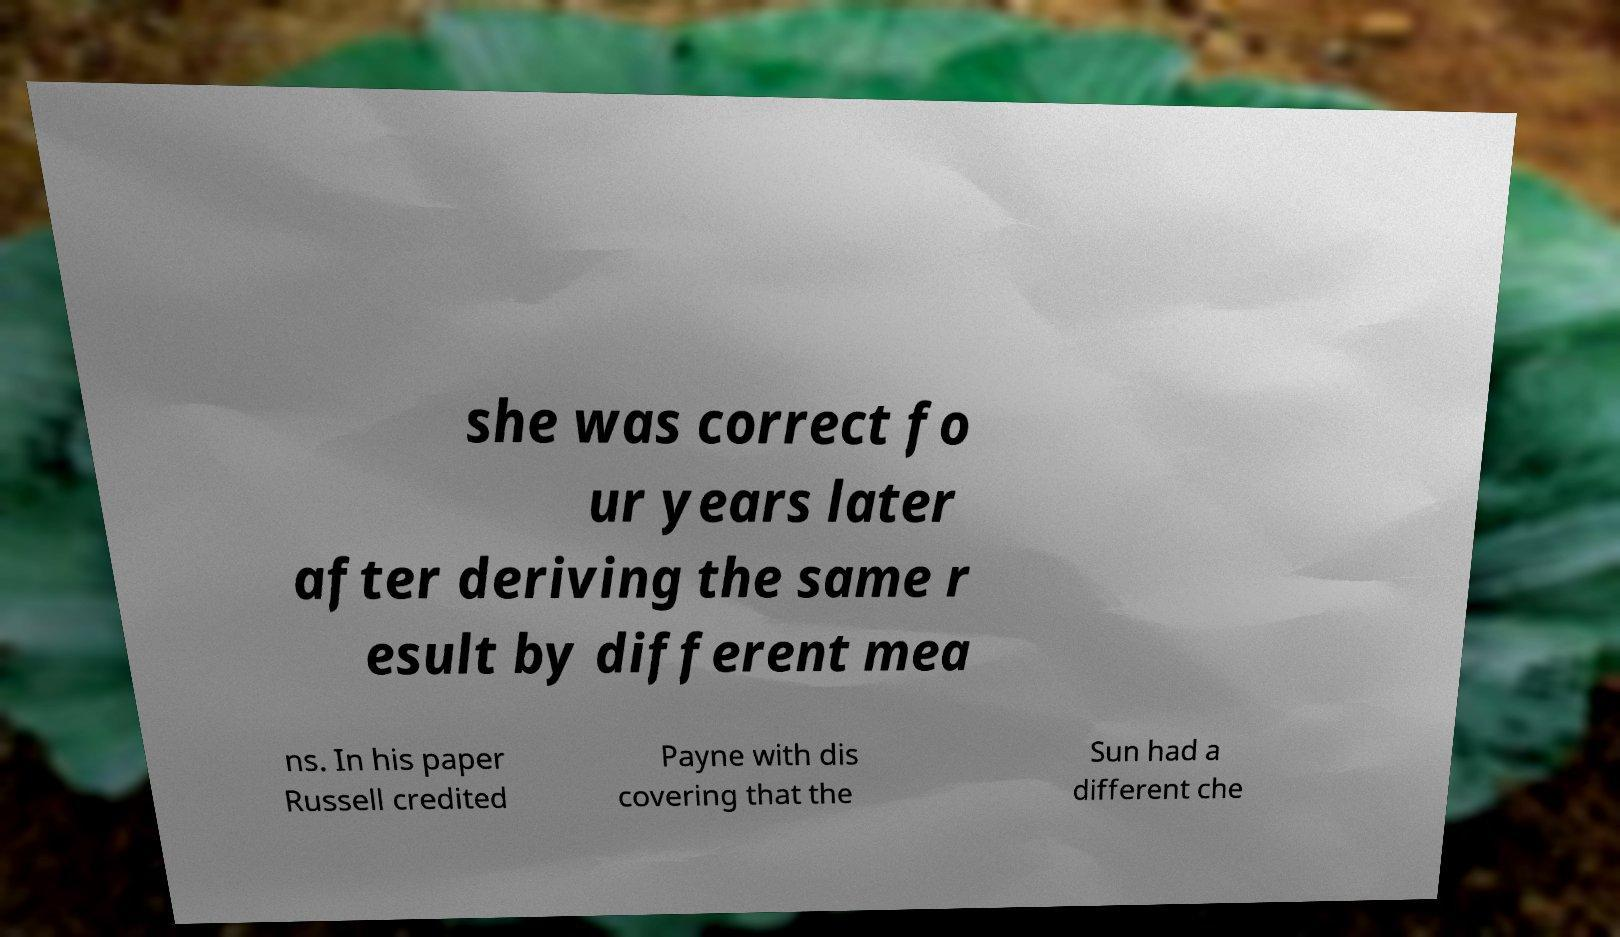Could you extract and type out the text from this image? she was correct fo ur years later after deriving the same r esult by different mea ns. In his paper Russell credited Payne with dis covering that the Sun had a different che 